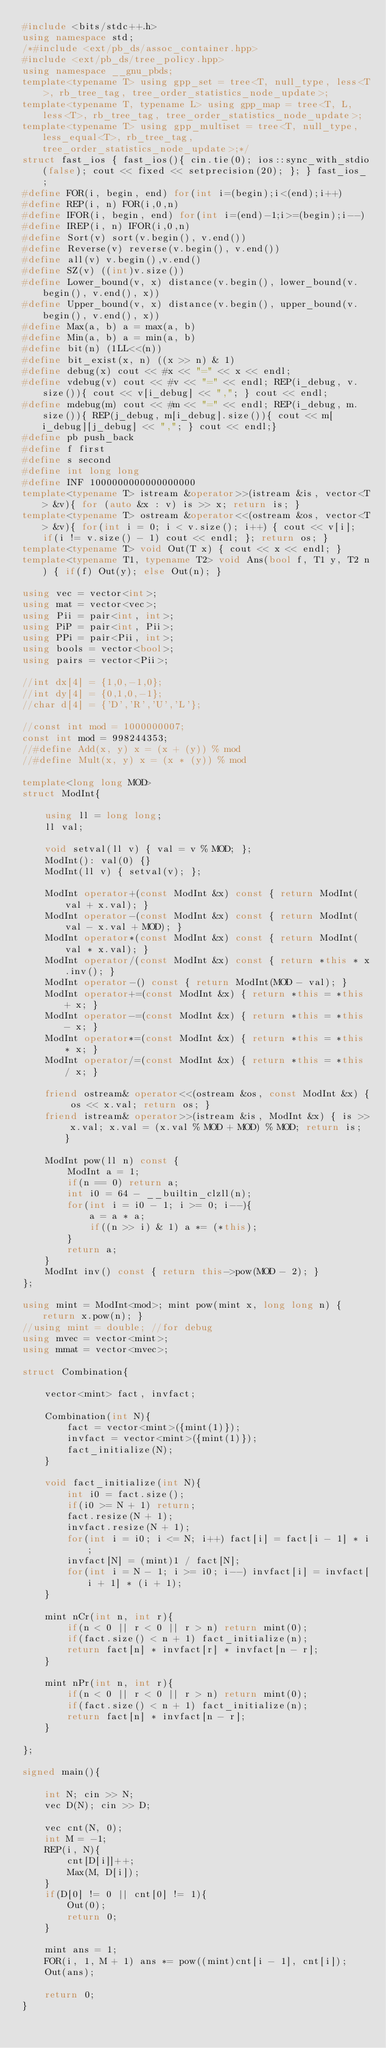Convert code to text. <code><loc_0><loc_0><loc_500><loc_500><_C++_>#include <bits/stdc++.h>
using namespace std;
/*#include <ext/pb_ds/assoc_container.hpp>
#include <ext/pb_ds/tree_policy.hpp>
using namespace __gnu_pbds;
template<typename T> using gpp_set = tree<T, null_type, less<T>, rb_tree_tag, tree_order_statistics_node_update>;
template<typename T, typename L> using gpp_map = tree<T, L, less<T>, rb_tree_tag, tree_order_statistics_node_update>;
template<typename T> using gpp_multiset = tree<T, null_type, less_equal<T>, rb_tree_tag, tree_order_statistics_node_update>;*/
struct fast_ios { fast_ios(){ cin.tie(0); ios::sync_with_stdio(false); cout << fixed << setprecision(20); }; } fast_ios_;
#define FOR(i, begin, end) for(int i=(begin);i<(end);i++)
#define REP(i, n) FOR(i,0,n)
#define IFOR(i, begin, end) for(int i=(end)-1;i>=(begin);i--)
#define IREP(i, n) IFOR(i,0,n)
#define Sort(v) sort(v.begin(), v.end())
#define Reverse(v) reverse(v.begin(), v.end())
#define all(v) v.begin(),v.end()
#define SZ(v) ((int)v.size())
#define Lower_bound(v, x) distance(v.begin(), lower_bound(v.begin(), v.end(), x))
#define Upper_bound(v, x) distance(v.begin(), upper_bound(v.begin(), v.end(), x))
#define Max(a, b) a = max(a, b)
#define Min(a, b) a = min(a, b)
#define bit(n) (1LL<<(n))
#define bit_exist(x, n) ((x >> n) & 1)
#define debug(x) cout << #x << "=" << x << endl;
#define vdebug(v) cout << #v << "=" << endl; REP(i_debug, v.size()){ cout << v[i_debug] << ","; } cout << endl;
#define mdebug(m) cout << #m << "=" << endl; REP(i_debug, m.size()){ REP(j_debug, m[i_debug].size()){ cout << m[i_debug][j_debug] << ","; } cout << endl;}
#define pb push_back
#define f first
#define s second
#define int long long
#define INF 1000000000000000000
template<typename T> istream &operator>>(istream &is, vector<T> &v){ for (auto &x : v) is >> x; return is; }
template<typename T> ostream &operator<<(ostream &os, vector<T> &v){ for(int i = 0; i < v.size(); i++) { cout << v[i]; if(i != v.size() - 1) cout << endl; }; return os; }
template<typename T> void Out(T x) { cout << x << endl; }
template<typename T1, typename T2> void Ans(bool f, T1 y, T2 n) { if(f) Out(y); else Out(n); }

using vec = vector<int>;
using mat = vector<vec>;
using Pii = pair<int, int>;
using PiP = pair<int, Pii>;
using PPi = pair<Pii, int>;
using bools = vector<bool>;
using pairs = vector<Pii>;

//int dx[4] = {1,0,-1,0};
//int dy[4] = {0,1,0,-1};
//char d[4] = {'D','R','U','L'};

//const int mod = 1000000007;
const int mod = 998244353;
//#define Add(x, y) x = (x + (y)) % mod
//#define Mult(x, y) x = (x * (y)) % mod

template<long long MOD>
struct ModInt{

    using ll = long long;
    ll val;

    void setval(ll v) { val = v % MOD; };
    ModInt(): val(0) {}
    ModInt(ll v) { setval(v); };

    ModInt operator+(const ModInt &x) const { return ModInt(val + x.val); }
    ModInt operator-(const ModInt &x) const { return ModInt(val - x.val + MOD); }
    ModInt operator*(const ModInt &x) const { return ModInt(val * x.val); }
    ModInt operator/(const ModInt &x) const { return *this * x.inv(); }
    ModInt operator-() const { return ModInt(MOD - val); }
    ModInt operator+=(const ModInt &x) { return *this = *this + x; }
    ModInt operator-=(const ModInt &x) { return *this = *this - x; }
    ModInt operator*=(const ModInt &x) { return *this = *this * x; }
    ModInt operator/=(const ModInt &x) { return *this = *this / x; }

    friend ostream& operator<<(ostream &os, const ModInt &x) { os << x.val; return os; }
    friend istream& operator>>(istream &is, ModInt &x) { is >> x.val; x.val = (x.val % MOD + MOD) % MOD; return is; }

    ModInt pow(ll n) const {
        ModInt a = 1;
        if(n == 0) return a;
        int i0 = 64 - __builtin_clzll(n);
        for(int i = i0 - 1; i >= 0; i--){
            a = a * a;
            if((n >> i) & 1) a *= (*this); 
        }
        return a;
    }
    ModInt inv() const { return this->pow(MOD - 2); }
};

using mint = ModInt<mod>; mint pow(mint x, long long n) { return x.pow(n); }
//using mint = double; //for debug
using mvec = vector<mint>;
using mmat = vector<mvec>;

struct Combination{

    vector<mint> fact, invfact;

    Combination(int N){
        fact = vector<mint>({mint(1)});
        invfact = vector<mint>({mint(1)});
        fact_initialize(N);
    }

    void fact_initialize(int N){
        int i0 = fact.size();
        if(i0 >= N + 1) return;
        fact.resize(N + 1);
        invfact.resize(N + 1);
        for(int i = i0; i <= N; i++) fact[i] = fact[i - 1] * i;
        invfact[N] = (mint)1 / fact[N];
        for(int i = N - 1; i >= i0; i--) invfact[i] = invfact[i + 1] * (i + 1); 
    }

    mint nCr(int n, int r){
        if(n < 0 || r < 0 || r > n) return mint(0);
        if(fact.size() < n + 1) fact_initialize(n);
        return fact[n] * invfact[r] * invfact[n - r];
    }

    mint nPr(int n, int r){
        if(n < 0 || r < 0 || r > n) return mint(0);
        if(fact.size() < n + 1) fact_initialize(n);
        return fact[n] * invfact[n - r];
    }

};

signed main(){

    int N; cin >> N;
    vec D(N); cin >> D;
    
    vec cnt(N, 0);
    int M = -1;
    REP(i, N){
        cnt[D[i]]++;
        Max(M, D[i]);
    }
    if(D[0] != 0 || cnt[0] != 1){
        Out(0);
        return 0;
    }

    mint ans = 1;
    FOR(i, 1, M + 1) ans *= pow((mint)cnt[i - 1], cnt[i]);
    Out(ans);

    return 0;
}
</code> 